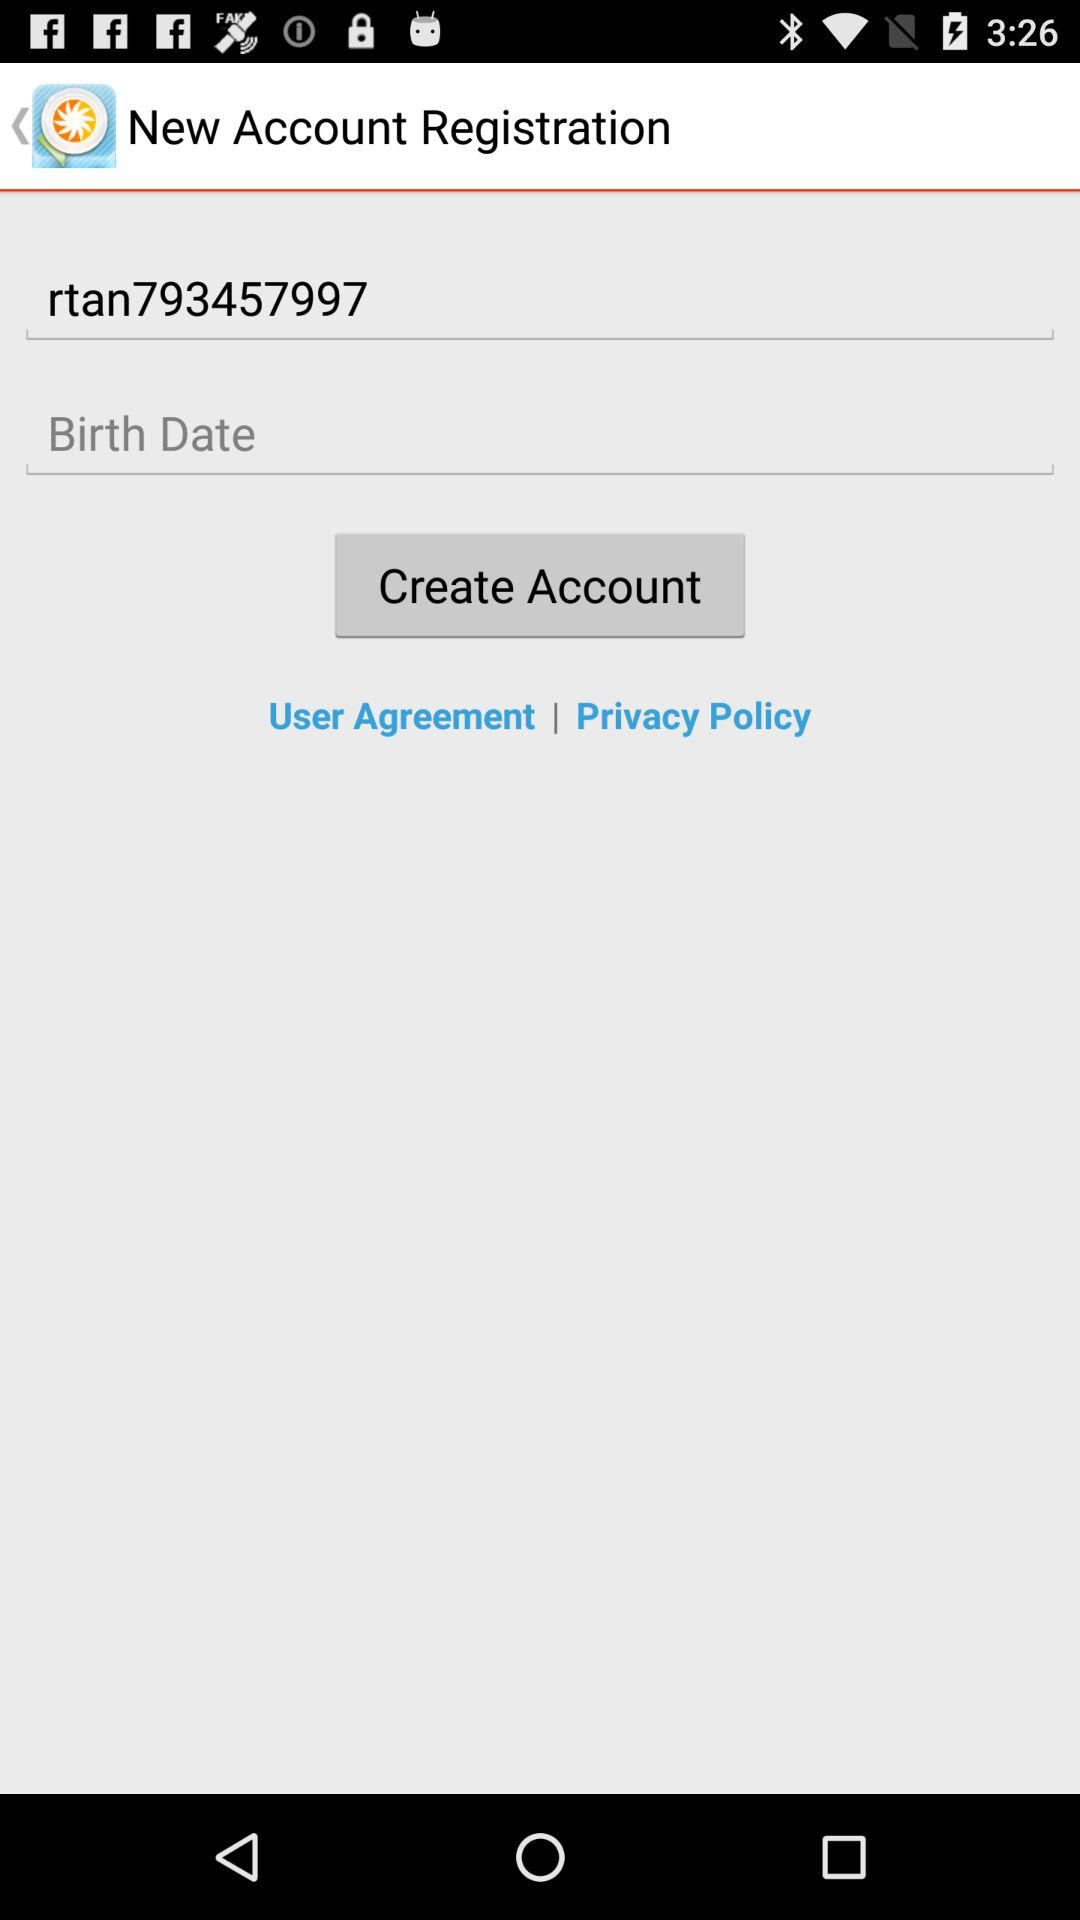What is the birth date?
When the provided information is insufficient, respond with <no answer>. <no answer> 